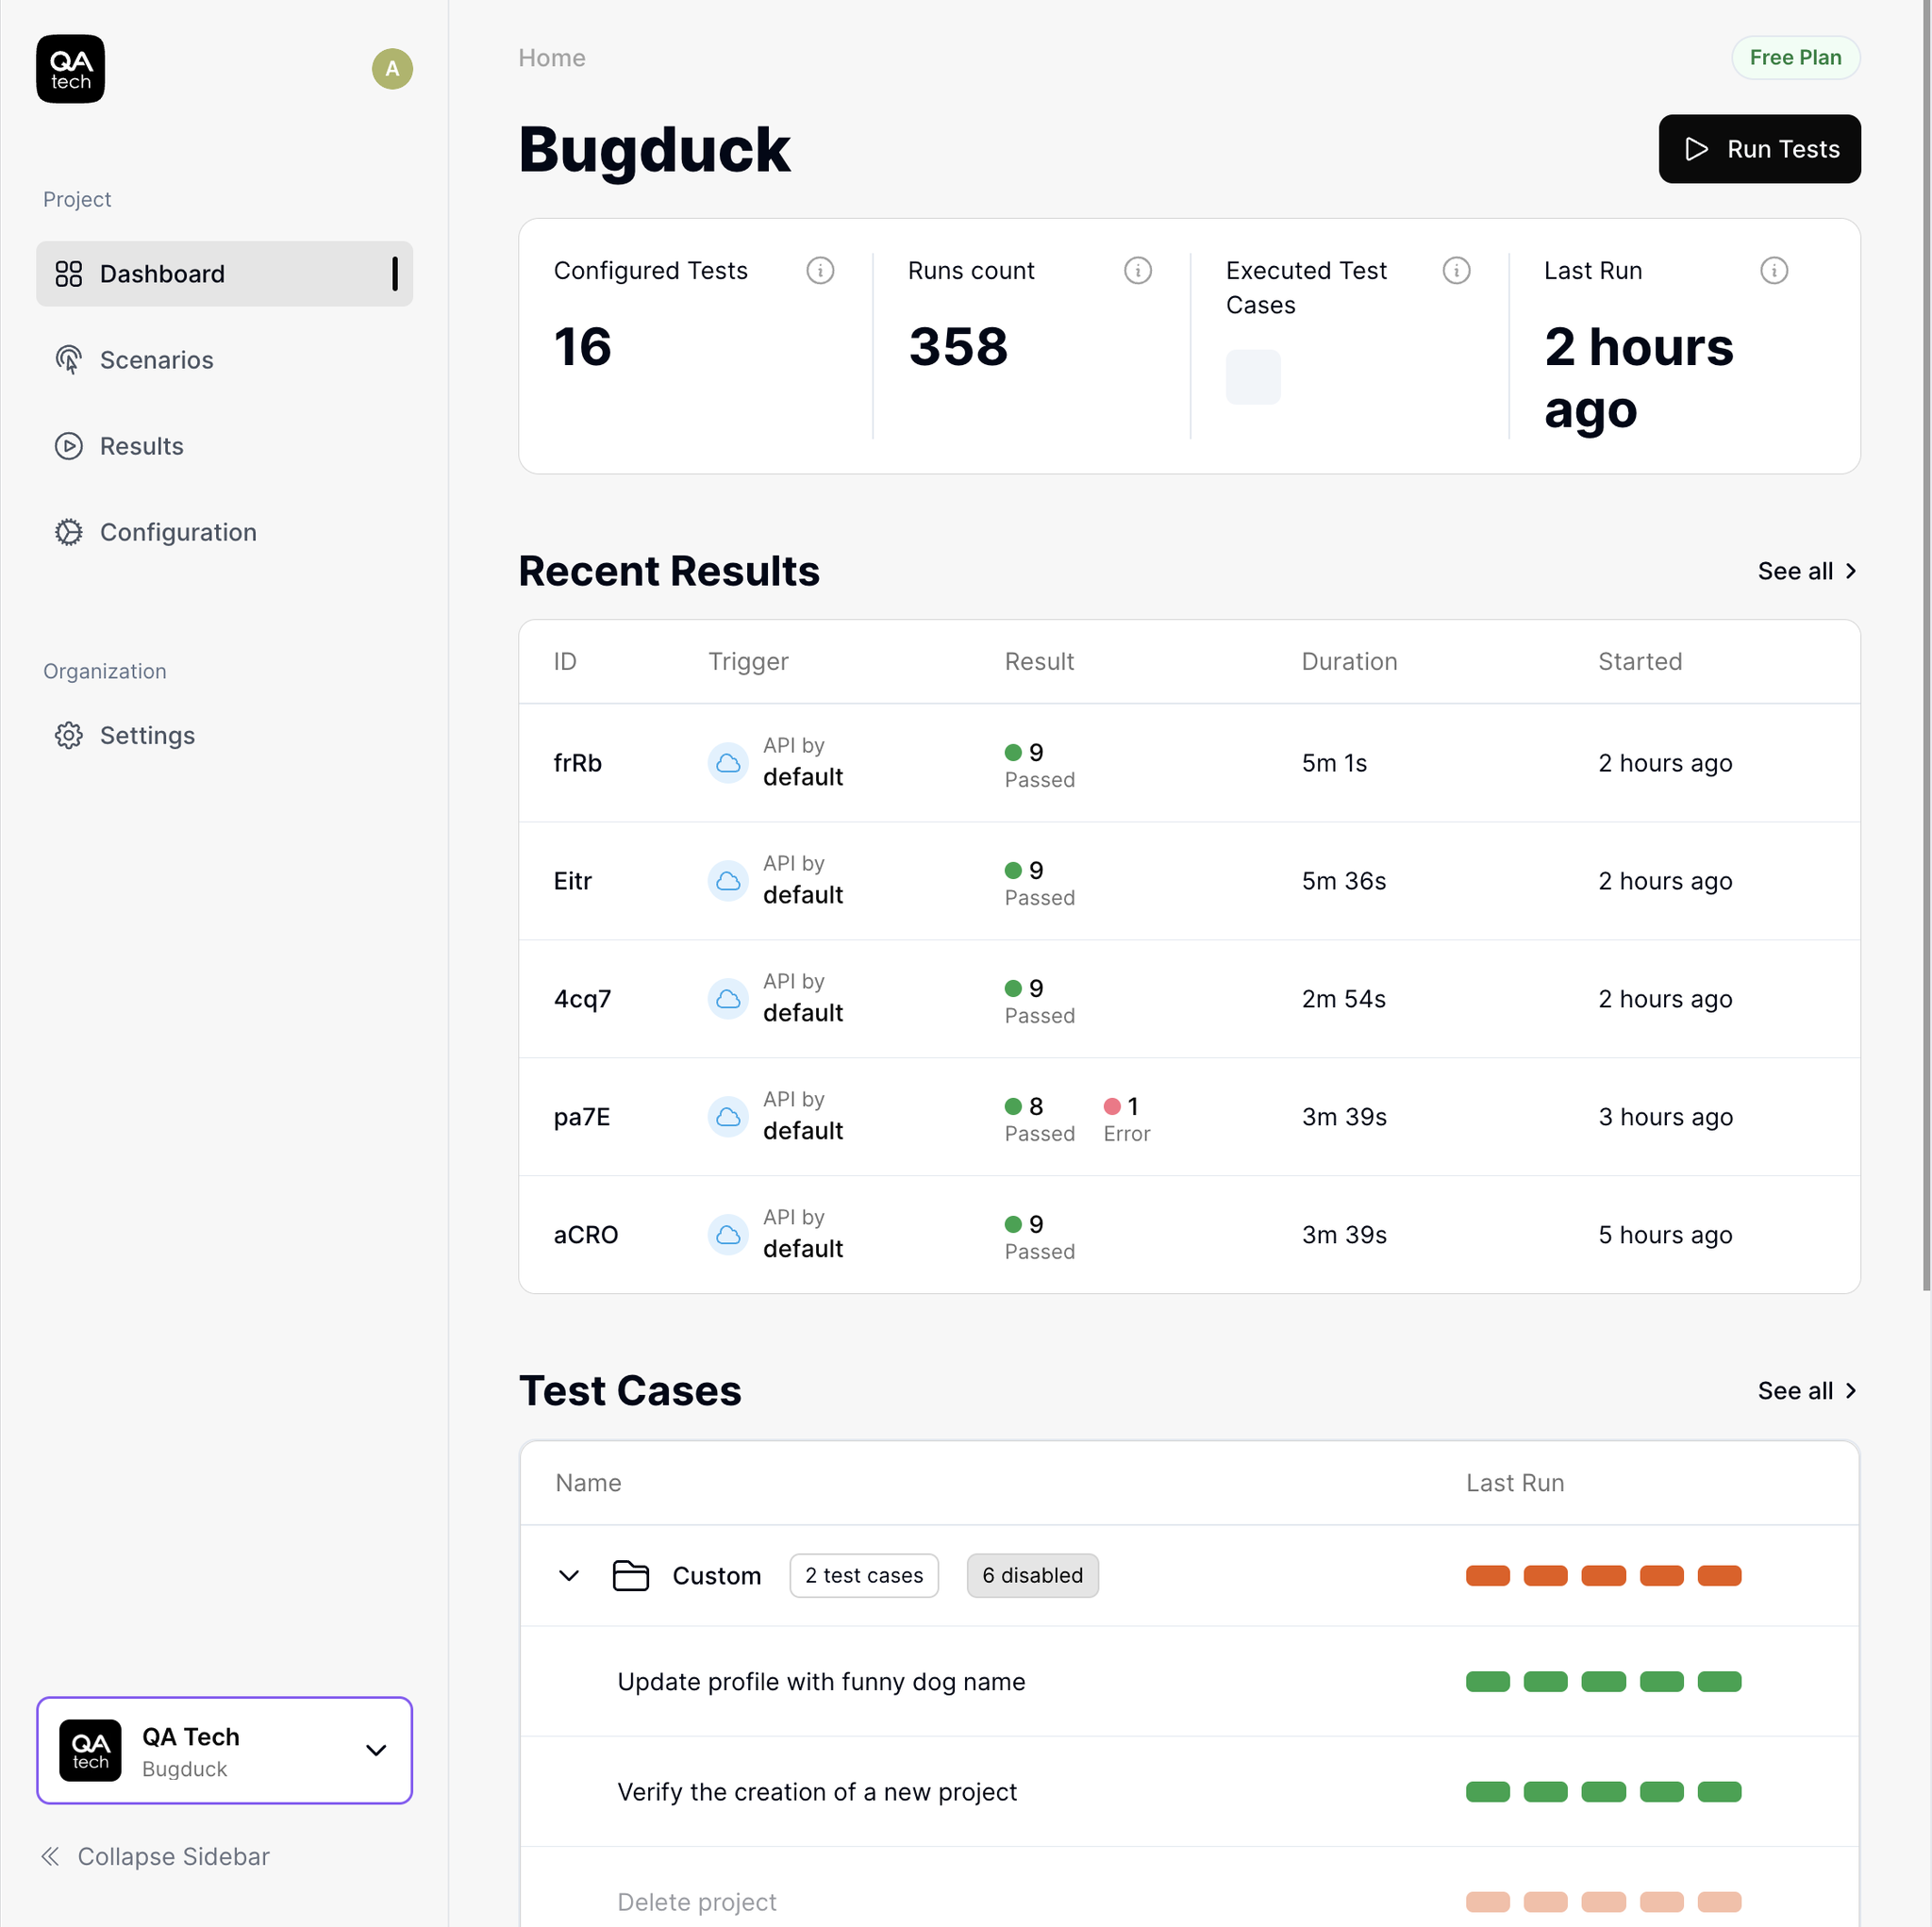Where is the user dropdown? The user dropdown menu is located in the lower-left corner of the image. It's marked by a logo with the letters "QA" inside a circle, next to the text "QA Tech" and "Bugduck." There is a downward arrow next to "Bugduck," indicating that it's a dropdown menu. 